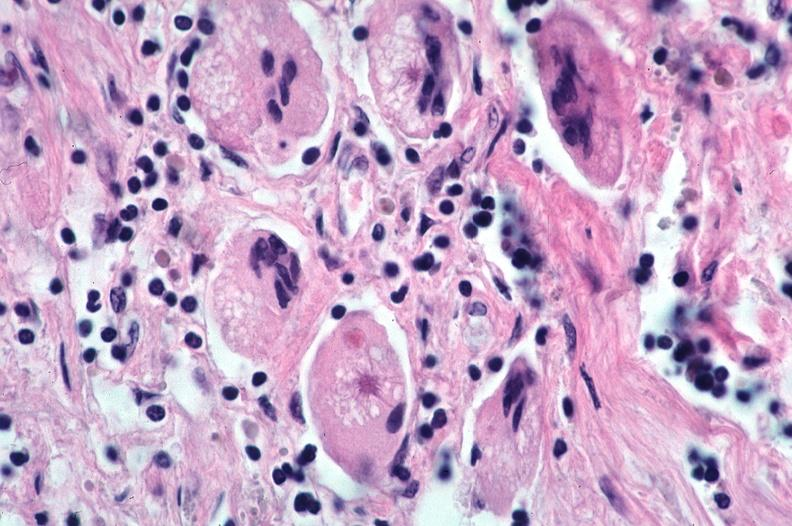what does this image show?
Answer the question using a single word or phrase. Lung 